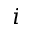Convert formula to latex. <formula><loc_0><loc_0><loc_500><loc_500>i</formula> 